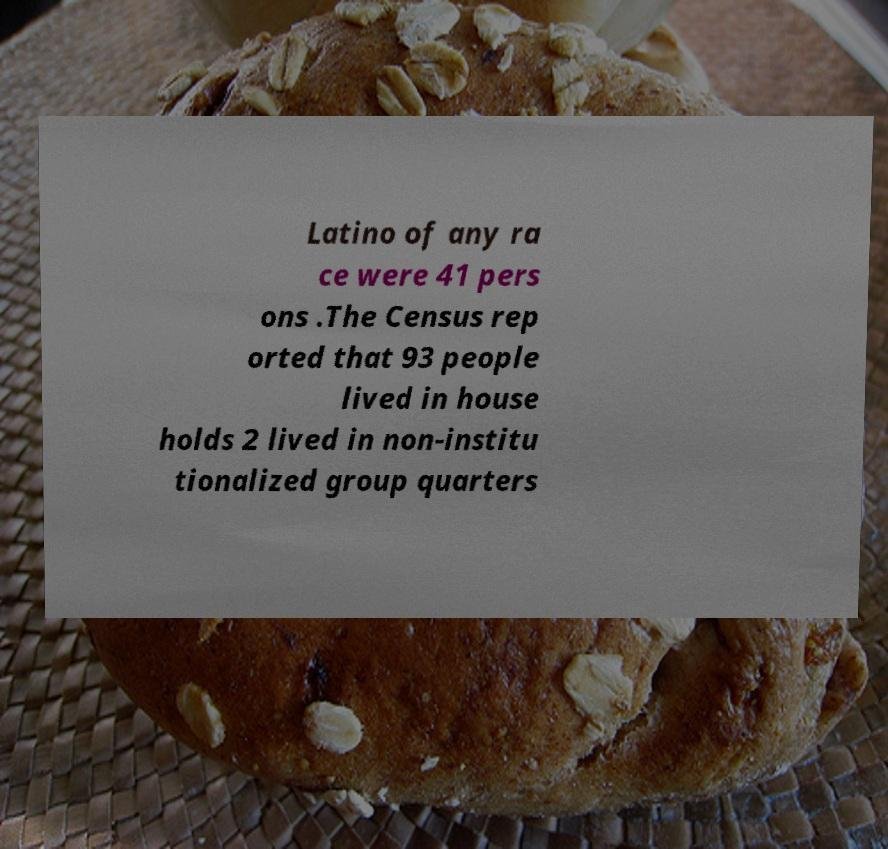Can you accurately transcribe the text from the provided image for me? Latino of any ra ce were 41 pers ons .The Census rep orted that 93 people lived in house holds 2 lived in non-institu tionalized group quarters 